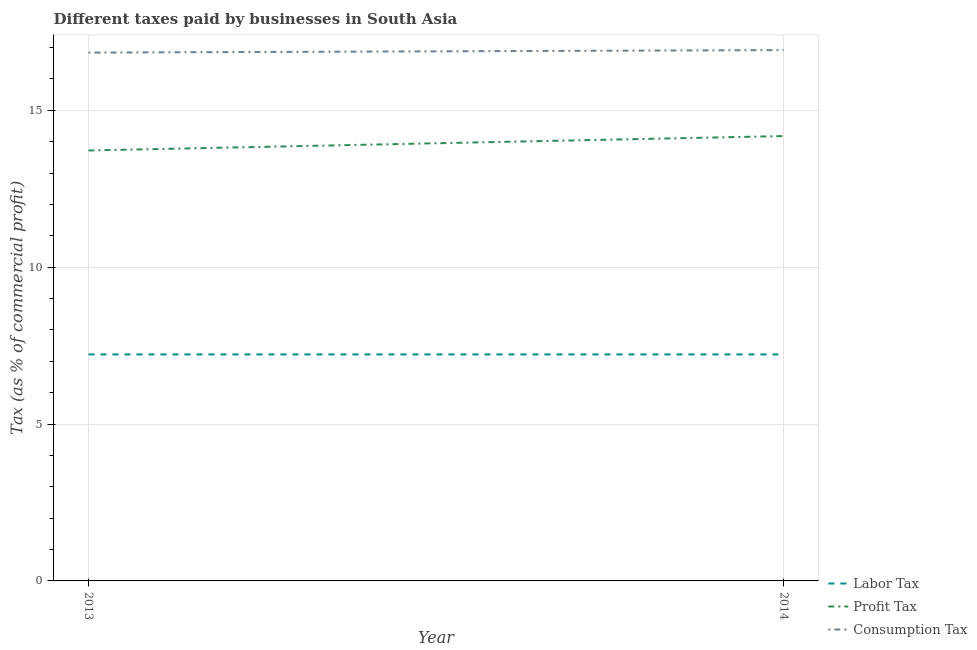How many different coloured lines are there?
Ensure brevity in your answer.  3. Does the line corresponding to percentage of labor tax intersect with the line corresponding to percentage of profit tax?
Provide a succinct answer. No. What is the percentage of profit tax in 2013?
Keep it short and to the point. 13.72. Across all years, what is the maximum percentage of labor tax?
Ensure brevity in your answer.  7.22. Across all years, what is the minimum percentage of labor tax?
Give a very brief answer. 7.22. In which year was the percentage of consumption tax maximum?
Offer a very short reply. 2014. What is the total percentage of consumption tax in the graph?
Make the answer very short. 33.76. What is the difference between the percentage of labor tax in 2013 and that in 2014?
Your answer should be very brief. 0. What is the difference between the percentage of profit tax in 2013 and the percentage of consumption tax in 2014?
Make the answer very short. -3.2. What is the average percentage of profit tax per year?
Offer a terse response. 13.95. In the year 2014, what is the difference between the percentage of profit tax and percentage of labor tax?
Your answer should be very brief. 6.96. What is the ratio of the percentage of consumption tax in 2013 to that in 2014?
Offer a very short reply. 1. Is the percentage of profit tax in 2013 less than that in 2014?
Your response must be concise. Yes. In how many years, is the percentage of profit tax greater than the average percentage of profit tax taken over all years?
Provide a succinct answer. 1. Is it the case that in every year, the sum of the percentage of labor tax and percentage of profit tax is greater than the percentage of consumption tax?
Make the answer very short. Yes. Does the percentage of labor tax monotonically increase over the years?
Make the answer very short. No. Is the percentage of profit tax strictly greater than the percentage of labor tax over the years?
Offer a very short reply. Yes. How many lines are there?
Keep it short and to the point. 3. How many years are there in the graph?
Make the answer very short. 2. What is the difference between two consecutive major ticks on the Y-axis?
Your answer should be compact. 5. Does the graph contain any zero values?
Your response must be concise. No. How are the legend labels stacked?
Offer a terse response. Vertical. What is the title of the graph?
Offer a terse response. Different taxes paid by businesses in South Asia. Does "Central government" appear as one of the legend labels in the graph?
Ensure brevity in your answer.  No. What is the label or title of the X-axis?
Your response must be concise. Year. What is the label or title of the Y-axis?
Your response must be concise. Tax (as % of commercial profit). What is the Tax (as % of commercial profit) in Labor Tax in 2013?
Give a very brief answer. 7.22. What is the Tax (as % of commercial profit) in Profit Tax in 2013?
Give a very brief answer. 13.72. What is the Tax (as % of commercial profit) in Consumption Tax in 2013?
Your answer should be compact. 16.84. What is the Tax (as % of commercial profit) of Labor Tax in 2014?
Offer a very short reply. 7.22. What is the Tax (as % of commercial profit) in Profit Tax in 2014?
Provide a short and direct response. 14.18. What is the Tax (as % of commercial profit) of Consumption Tax in 2014?
Your answer should be very brief. 16.92. Across all years, what is the maximum Tax (as % of commercial profit) of Labor Tax?
Your response must be concise. 7.22. Across all years, what is the maximum Tax (as % of commercial profit) in Profit Tax?
Your answer should be very brief. 14.18. Across all years, what is the maximum Tax (as % of commercial profit) of Consumption Tax?
Offer a very short reply. 16.92. Across all years, what is the minimum Tax (as % of commercial profit) in Labor Tax?
Ensure brevity in your answer.  7.22. Across all years, what is the minimum Tax (as % of commercial profit) in Profit Tax?
Your response must be concise. 13.72. Across all years, what is the minimum Tax (as % of commercial profit) in Consumption Tax?
Keep it short and to the point. 16.84. What is the total Tax (as % of commercial profit) of Labor Tax in the graph?
Offer a very short reply. 14.44. What is the total Tax (as % of commercial profit) of Profit Tax in the graph?
Offer a very short reply. 27.9. What is the total Tax (as % of commercial profit) in Consumption Tax in the graph?
Give a very brief answer. 33.76. What is the difference between the Tax (as % of commercial profit) of Labor Tax in 2013 and that in 2014?
Keep it short and to the point. 0. What is the difference between the Tax (as % of commercial profit) of Profit Tax in 2013 and that in 2014?
Provide a succinct answer. -0.46. What is the difference between the Tax (as % of commercial profit) of Consumption Tax in 2013 and that in 2014?
Ensure brevity in your answer.  -0.08. What is the difference between the Tax (as % of commercial profit) in Labor Tax in 2013 and the Tax (as % of commercial profit) in Profit Tax in 2014?
Keep it short and to the point. -6.96. What is the difference between the Tax (as % of commercial profit) in Profit Tax in 2013 and the Tax (as % of commercial profit) in Consumption Tax in 2014?
Offer a terse response. -3.2. What is the average Tax (as % of commercial profit) of Labor Tax per year?
Your answer should be compact. 7.22. What is the average Tax (as % of commercial profit) in Profit Tax per year?
Provide a succinct answer. 13.95. What is the average Tax (as % of commercial profit) in Consumption Tax per year?
Your answer should be very brief. 16.88. In the year 2013, what is the difference between the Tax (as % of commercial profit) in Labor Tax and Tax (as % of commercial profit) in Consumption Tax?
Your answer should be compact. -9.62. In the year 2013, what is the difference between the Tax (as % of commercial profit) in Profit Tax and Tax (as % of commercial profit) in Consumption Tax?
Offer a terse response. -3.12. In the year 2014, what is the difference between the Tax (as % of commercial profit) of Labor Tax and Tax (as % of commercial profit) of Profit Tax?
Provide a succinct answer. -6.96. In the year 2014, what is the difference between the Tax (as % of commercial profit) in Labor Tax and Tax (as % of commercial profit) in Consumption Tax?
Ensure brevity in your answer.  -9.7. In the year 2014, what is the difference between the Tax (as % of commercial profit) in Profit Tax and Tax (as % of commercial profit) in Consumption Tax?
Your response must be concise. -2.74. What is the ratio of the Tax (as % of commercial profit) of Profit Tax in 2013 to that in 2014?
Your response must be concise. 0.97. What is the ratio of the Tax (as % of commercial profit) of Consumption Tax in 2013 to that in 2014?
Offer a terse response. 1. What is the difference between the highest and the second highest Tax (as % of commercial profit) in Profit Tax?
Make the answer very short. 0.46. What is the difference between the highest and the second highest Tax (as % of commercial profit) in Consumption Tax?
Offer a terse response. 0.08. What is the difference between the highest and the lowest Tax (as % of commercial profit) of Labor Tax?
Ensure brevity in your answer.  0. What is the difference between the highest and the lowest Tax (as % of commercial profit) in Profit Tax?
Give a very brief answer. 0.46. What is the difference between the highest and the lowest Tax (as % of commercial profit) in Consumption Tax?
Make the answer very short. 0.08. 